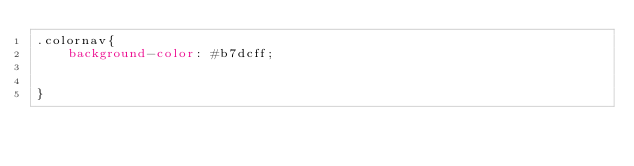<code> <loc_0><loc_0><loc_500><loc_500><_CSS_>.colornav{
    background-color: #b7dcff;


}</code> 